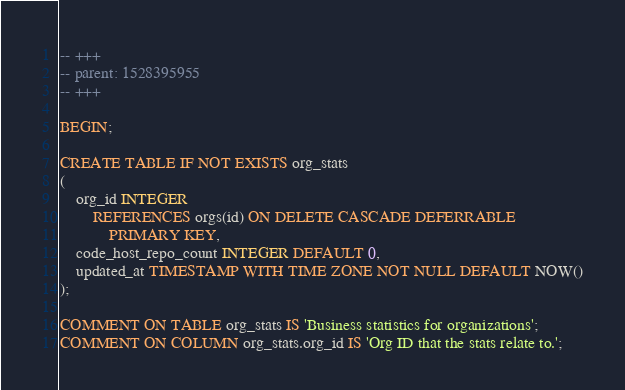Convert code to text. <code><loc_0><loc_0><loc_500><loc_500><_SQL_>-- +++
-- parent: 1528395955
-- +++

BEGIN;

CREATE TABLE IF NOT EXISTS org_stats
(
    org_id INTEGER
        REFERENCES orgs(id) ON DELETE CASCADE DEFERRABLE
            PRIMARY KEY,
    code_host_repo_count INTEGER DEFAULT 0,
    updated_at TIMESTAMP WITH TIME ZONE NOT NULL DEFAULT NOW()
);

COMMENT ON TABLE org_stats IS 'Business statistics for organizations';
COMMENT ON COLUMN org_stats.org_id IS 'Org ID that the stats relate to.';</code> 